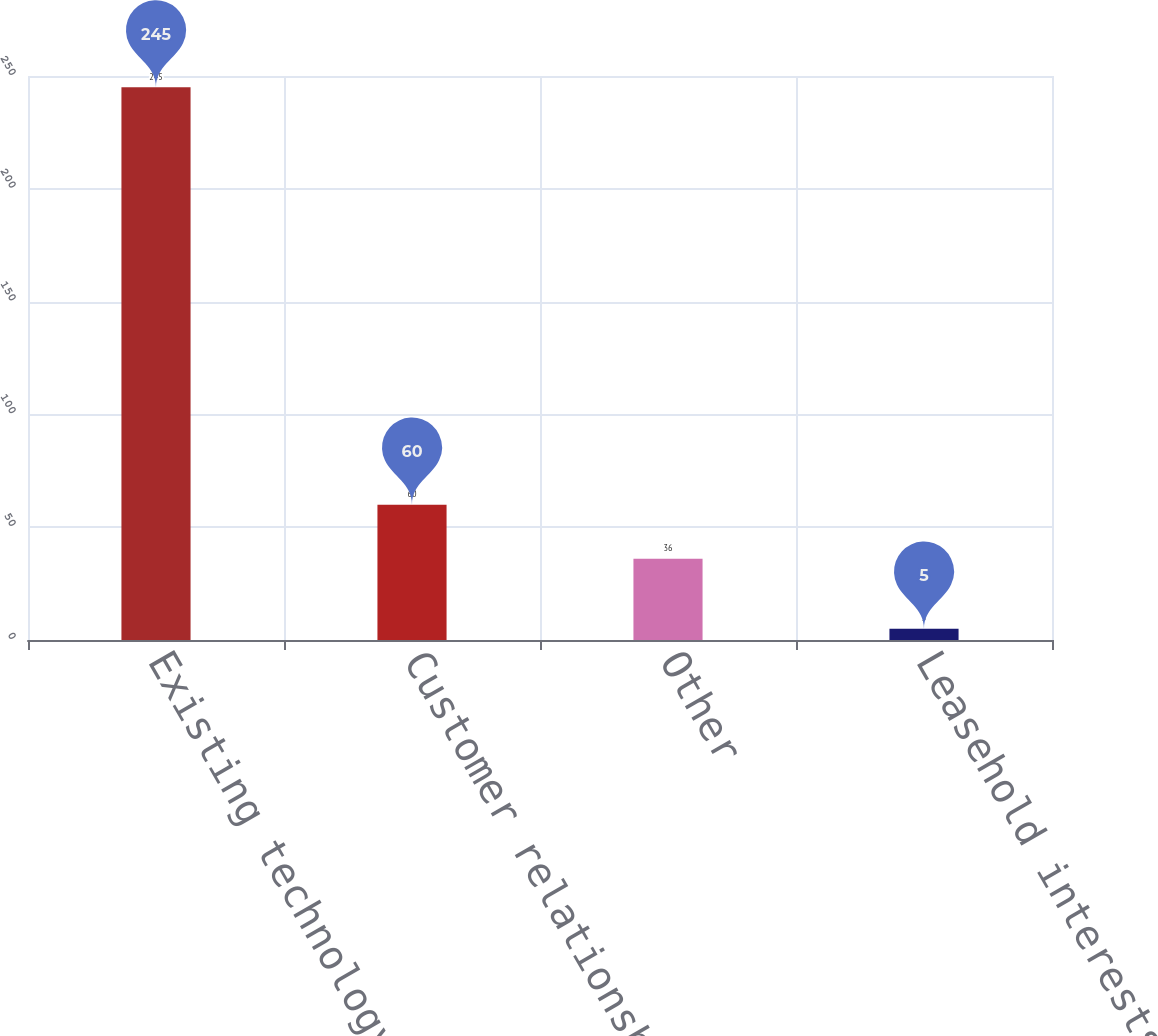Convert chart to OTSL. <chart><loc_0><loc_0><loc_500><loc_500><bar_chart><fcel>Existing technology<fcel>Customer relationships<fcel>Other<fcel>Leasehold interests<nl><fcel>245<fcel>60<fcel>36<fcel>5<nl></chart> 